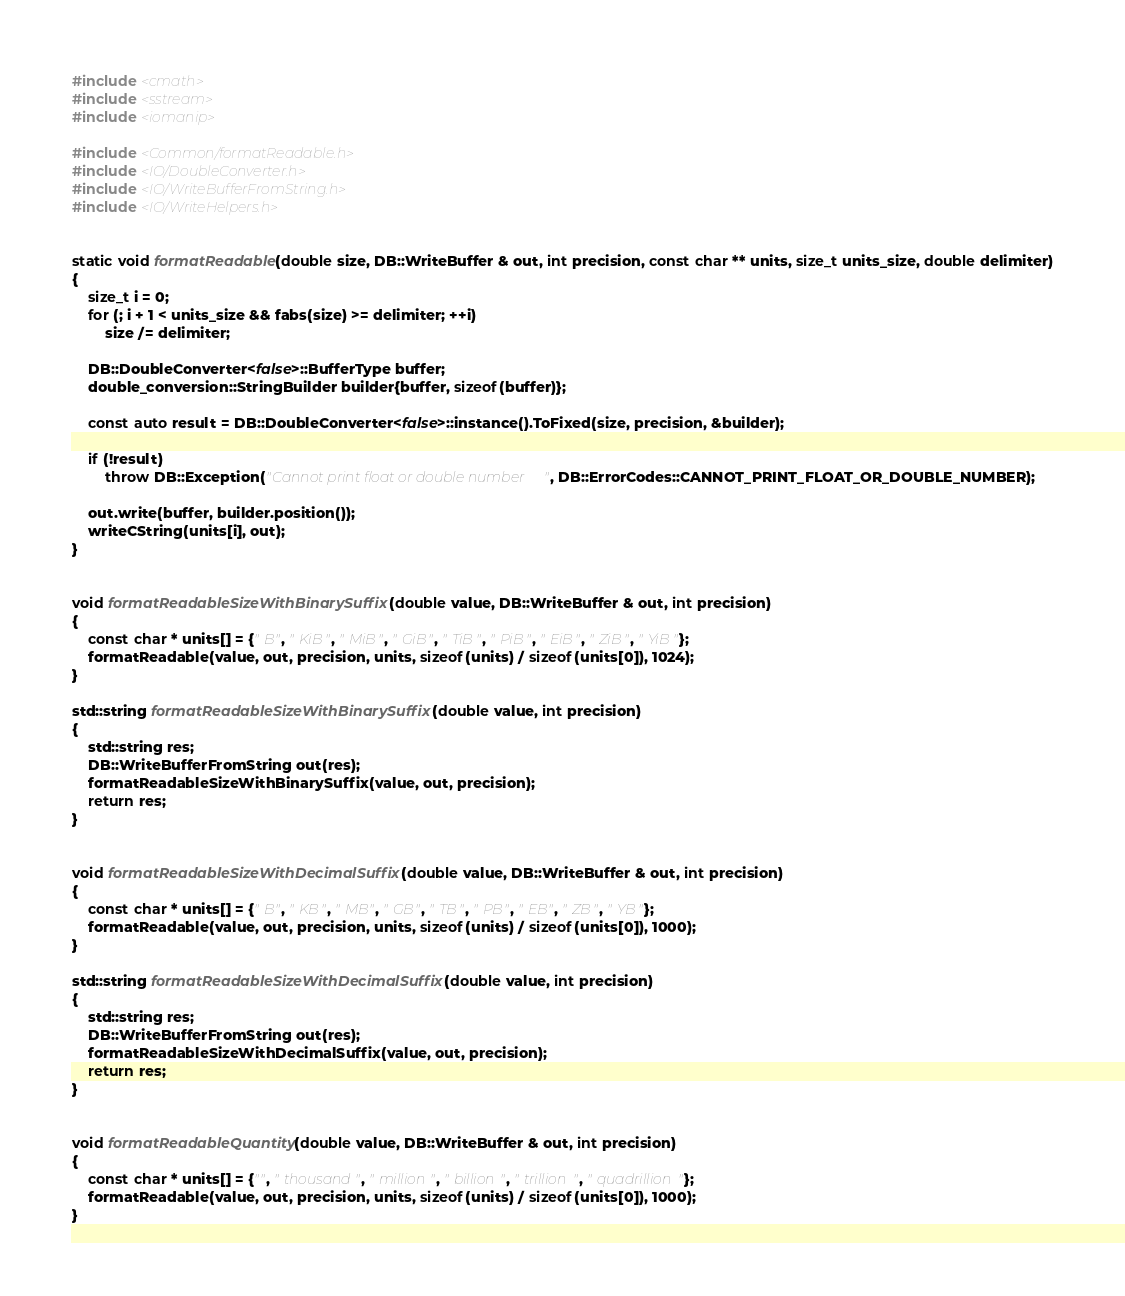<code> <loc_0><loc_0><loc_500><loc_500><_C++_>#include <cmath>
#include <sstream>
#include <iomanip>

#include <Common/formatReadable.h>
#include <IO/DoubleConverter.h>
#include <IO/WriteBufferFromString.h>
#include <IO/WriteHelpers.h>


static void formatReadable(double size, DB::WriteBuffer & out, int precision, const char ** units, size_t units_size, double delimiter)
{
    size_t i = 0;
    for (; i + 1 < units_size && fabs(size) >= delimiter; ++i)
        size /= delimiter;

    DB::DoubleConverter<false>::BufferType buffer;
    double_conversion::StringBuilder builder{buffer, sizeof(buffer)};

    const auto result = DB::DoubleConverter<false>::instance().ToFixed(size, precision, &builder);

    if (!result)
        throw DB::Exception("Cannot print float or double number", DB::ErrorCodes::CANNOT_PRINT_FLOAT_OR_DOUBLE_NUMBER);

    out.write(buffer, builder.position());
    writeCString(units[i], out);
}


void formatReadableSizeWithBinarySuffix(double value, DB::WriteBuffer & out, int precision)
{
    const char * units[] = {" B", " KiB", " MiB", " GiB", " TiB", " PiB", " EiB", " ZiB", " YiB"};
    formatReadable(value, out, precision, units, sizeof(units) / sizeof(units[0]), 1024);
}

std::string formatReadableSizeWithBinarySuffix(double value, int precision)
{
    std::string res;
    DB::WriteBufferFromString out(res);
    formatReadableSizeWithBinarySuffix(value, out, precision);
    return res;
}


void formatReadableSizeWithDecimalSuffix(double value, DB::WriteBuffer & out, int precision)
{
    const char * units[] = {" B", " KB", " MB", " GB", " TB", " PB", " EB", " ZB", " YB"};
    formatReadable(value, out, precision, units, sizeof(units) / sizeof(units[0]), 1000);
}

std::string formatReadableSizeWithDecimalSuffix(double value, int precision)
{
    std::string res;
    DB::WriteBufferFromString out(res);
    formatReadableSizeWithDecimalSuffix(value, out, precision);
    return res;
}


void formatReadableQuantity(double value, DB::WriteBuffer & out, int precision)
{
    const char * units[] = {"", " thousand", " million", " billion", " trillion", " quadrillion"};
    formatReadable(value, out, precision, units, sizeof(units) / sizeof(units[0]), 1000);
}
</code> 